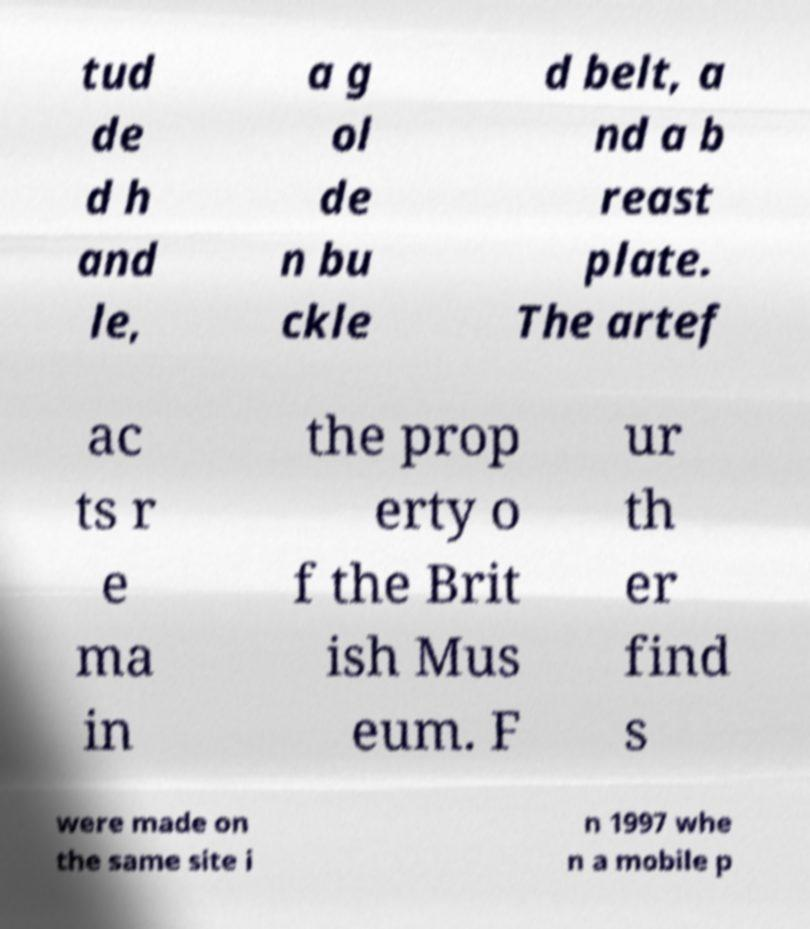Can you accurately transcribe the text from the provided image for me? tud de d h and le, a g ol de n bu ckle d belt, a nd a b reast plate. The artef ac ts r e ma in the prop erty o f the Brit ish Mus eum. F ur th er find s were made on the same site i n 1997 whe n a mobile p 